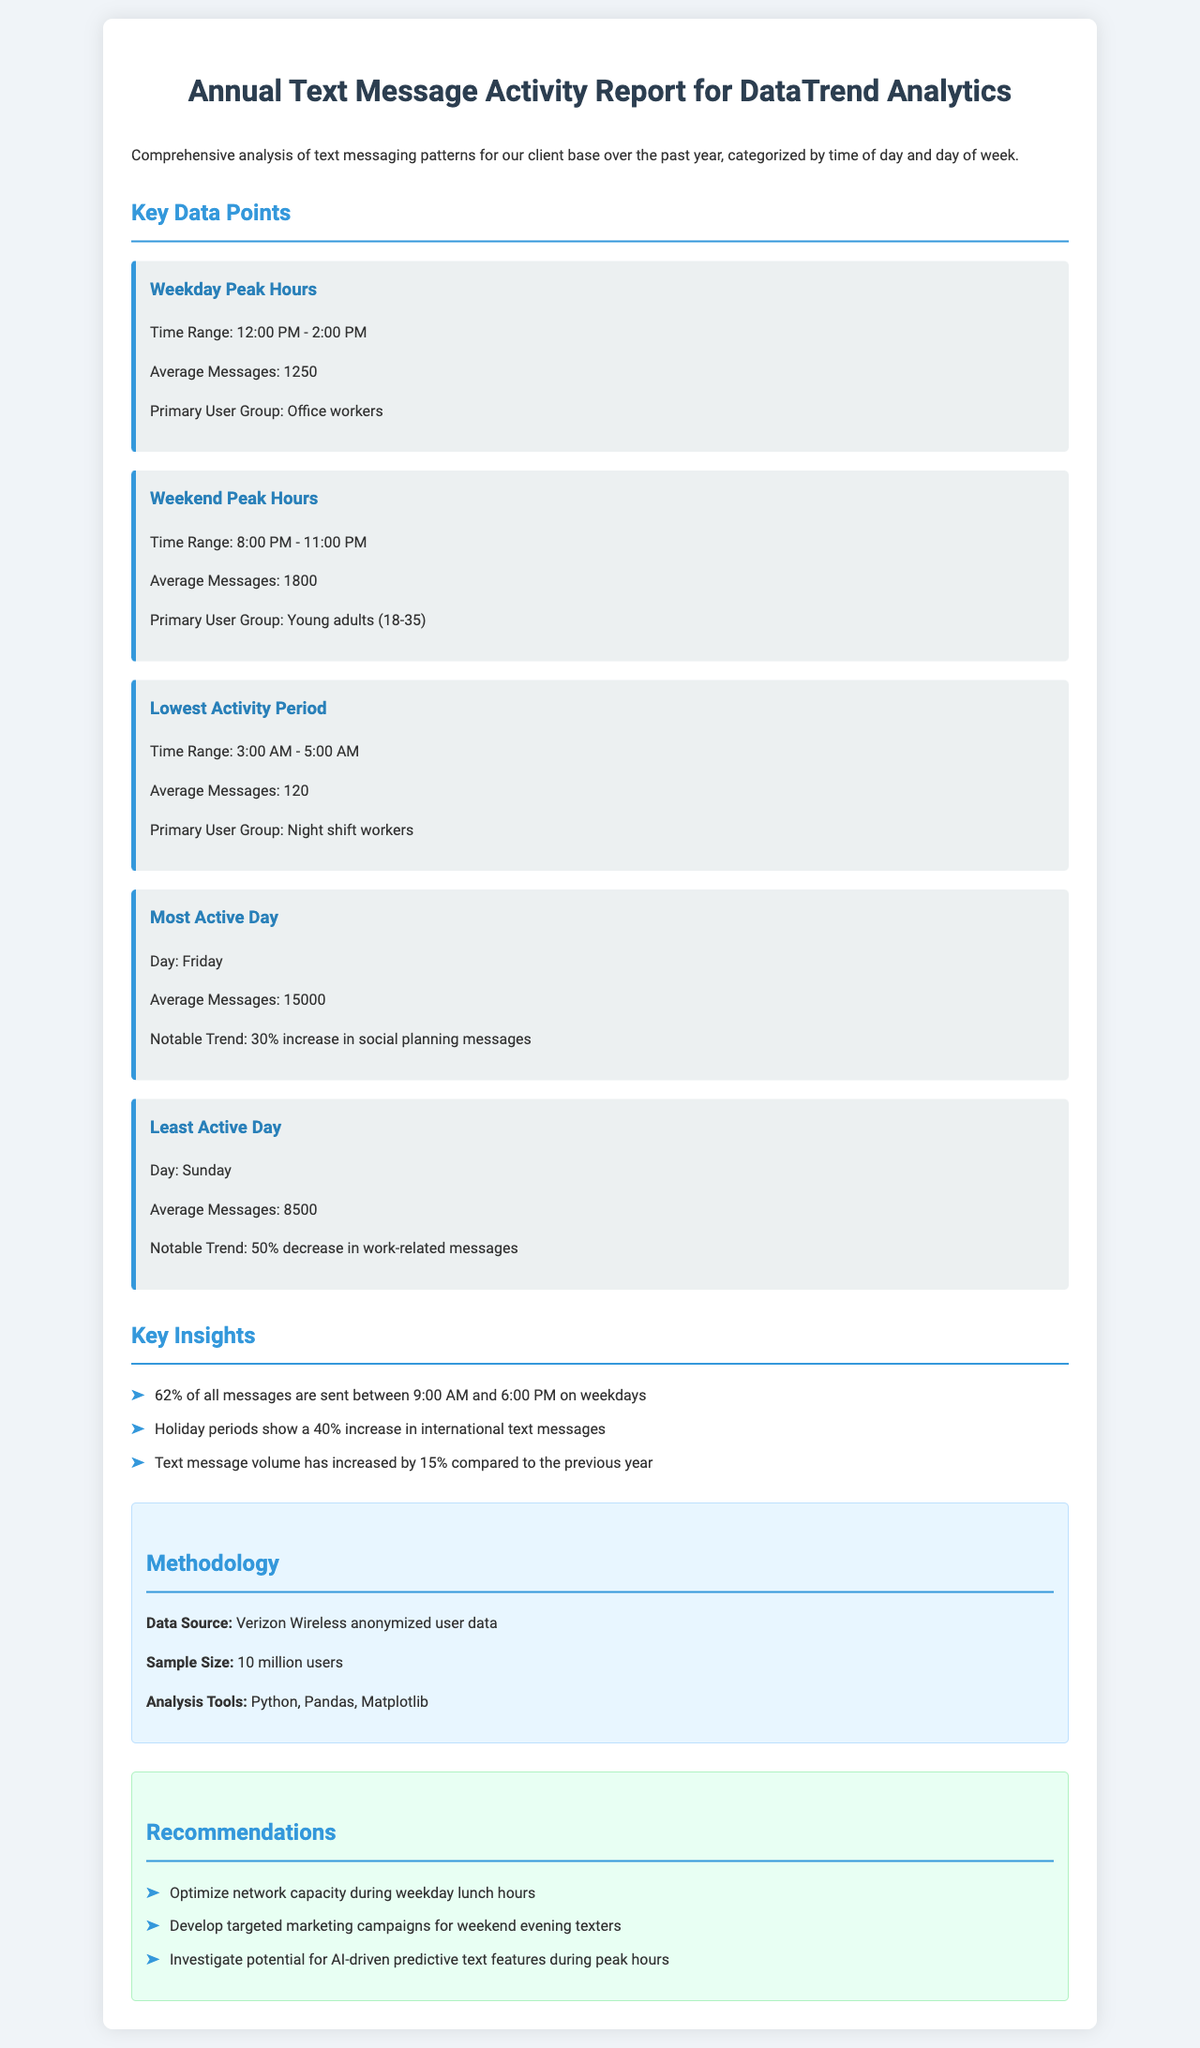What is the time range for weekday peak hours? The time range for weekday peak hours is provided in the data point titled "Weekday Peak Hours."
Answer: 12:00 PM - 2:00 PM What is the average number of messages during the weekend peak hours? The average number of messages during the weekend peak hours is mentioned under the "Weekend Peak Hours" data point.
Answer: 1800 Which day is identified as the most active day? The most active day is specified in the "Most Active Day" data point within the report.
Answer: Friday What percentage increase in social planning messages is observed on the most active day? The notable trend regarding social planning messages on the most active day is detailed in the corresponding data point.
Answer: 30% What is the average number of messages on Sunday? The average number of messages on Sunday is found in the "Least Active Day" data point.
Answer: 8500 What percentage of messages are sent between 9:00 AM and 6:00 PM on weekdays? This percentage is provided as a key insight within the document.
Answer: 62% Which analysis tool was used in the methodology section? The analysis tools utilized for the report are listed in the "Methodology" section.
Answer: Python What is the sample size of users for the analysis? The sample size is clearly mentioned in the "Methodology" section of the report.
Answer: 10 million users What notable trend is mentioned regarding holiday periods? The notable trend about holiday periods is shared among the key insights in the document.
Answer: 40% increase in international text messages 